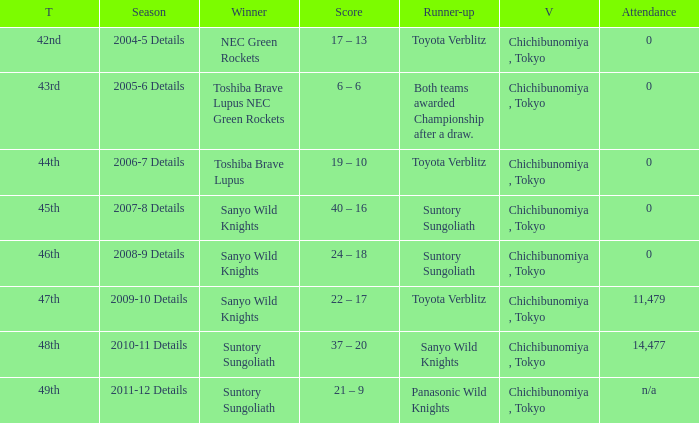What is the Score when the winner was suntory sungoliath, and the number attendance was n/a? 21 – 9. 